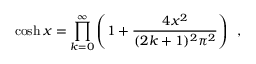Convert formula to latex. <formula><loc_0><loc_0><loc_500><loc_500>\cosh x = \prod _ { k = 0 } ^ { \infty } \left ( 1 + \frac { 4 x ^ { 2 } } { ( 2 k + 1 ) ^ { 2 } \pi ^ { 2 } } \right ) \, ,</formula> 